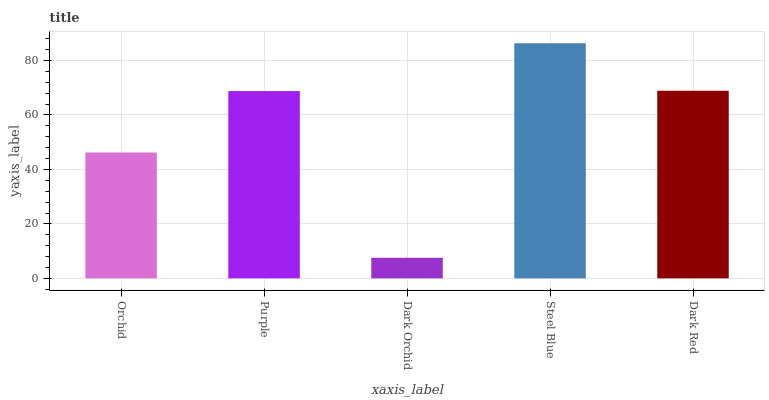Is Dark Orchid the minimum?
Answer yes or no. Yes. Is Steel Blue the maximum?
Answer yes or no. Yes. Is Purple the minimum?
Answer yes or no. No. Is Purple the maximum?
Answer yes or no. No. Is Purple greater than Orchid?
Answer yes or no. Yes. Is Orchid less than Purple?
Answer yes or no. Yes. Is Orchid greater than Purple?
Answer yes or no. No. Is Purple less than Orchid?
Answer yes or no. No. Is Purple the high median?
Answer yes or no. Yes. Is Purple the low median?
Answer yes or no. Yes. Is Dark Red the high median?
Answer yes or no. No. Is Steel Blue the low median?
Answer yes or no. No. 